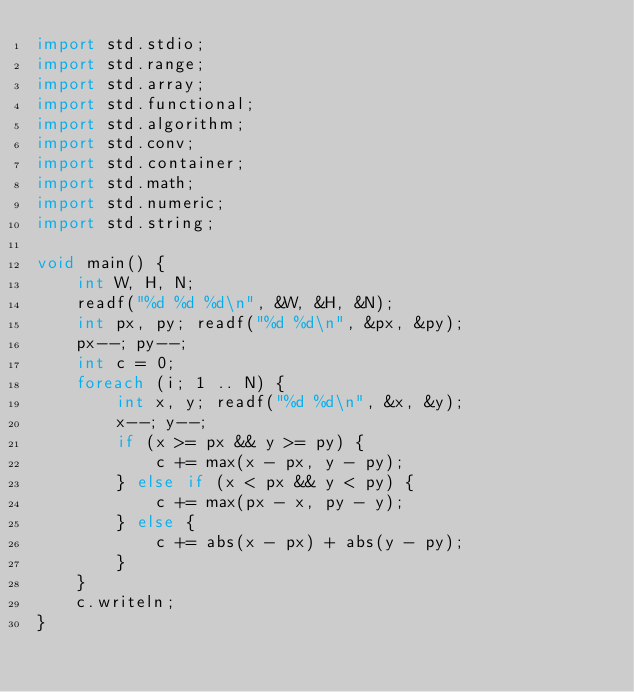Convert code to text. <code><loc_0><loc_0><loc_500><loc_500><_D_>import std.stdio;
import std.range;
import std.array;
import std.functional;
import std.algorithm;
import std.conv;
import std.container;
import std.math;
import std.numeric;
import std.string;

void main() {
    int W, H, N;
    readf("%d %d %d\n", &W, &H, &N);
    int px, py; readf("%d %d\n", &px, &py);
    px--; py--;
    int c = 0;
    foreach (i; 1 .. N) {
        int x, y; readf("%d %d\n", &x, &y);
        x--; y--;
        if (x >= px && y >= py) {
            c += max(x - px, y - py);
        } else if (x < px && y < py) {
            c += max(px - x, py - y);
        } else {
            c += abs(x - px) + abs(y - py);
        }
    }
    c.writeln;
}</code> 